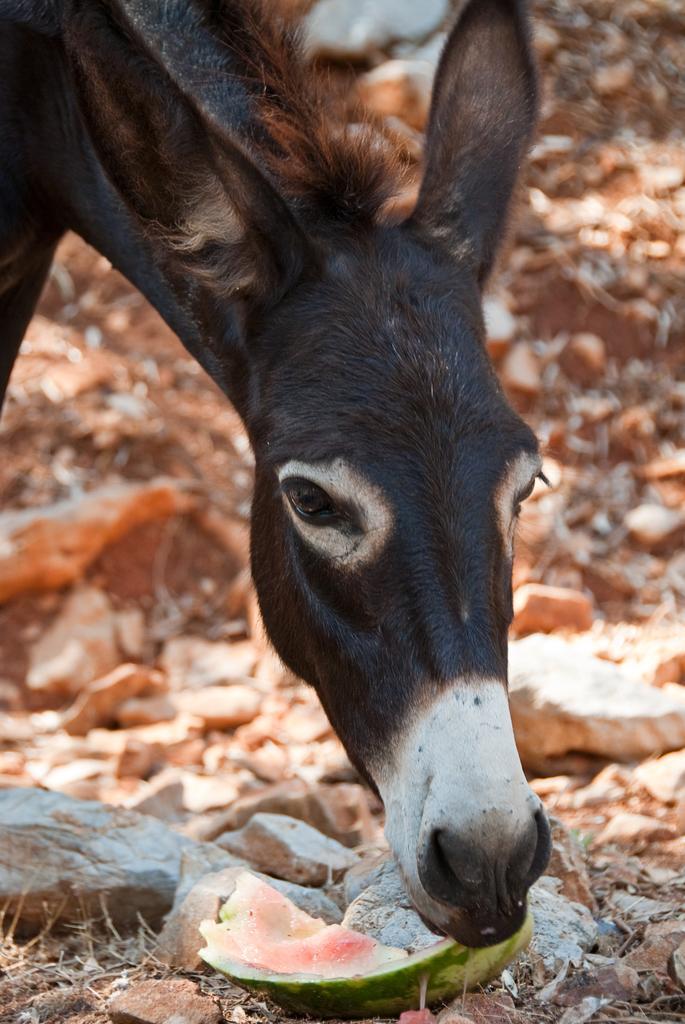Can you describe this image briefly? In the picture I can see donkey eating a watermelon, side there are some stones and dry leaves. 